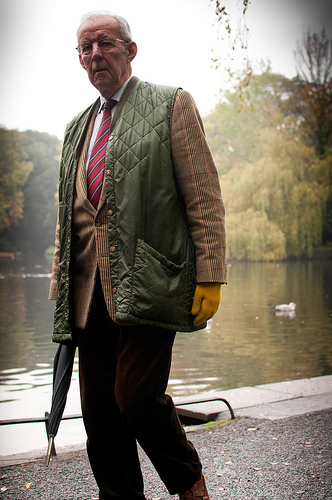<image>
Can you confirm if the head is next to the sky? No. The head is not positioned next to the sky. They are located in different areas of the scene. 